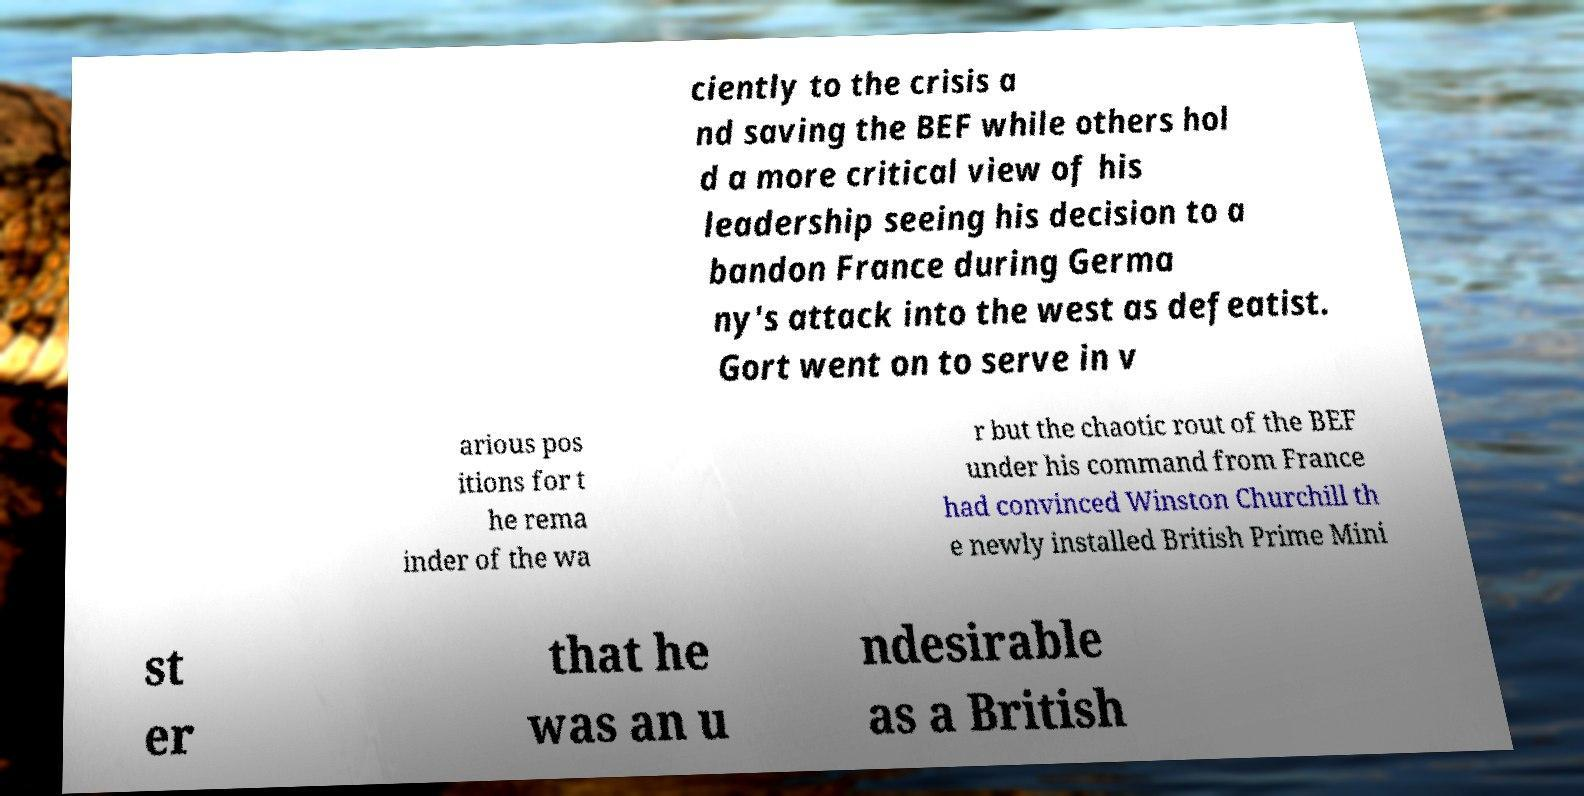Can you accurately transcribe the text from the provided image for me? ciently to the crisis a nd saving the BEF while others hol d a more critical view of his leadership seeing his decision to a bandon France during Germa ny's attack into the west as defeatist. Gort went on to serve in v arious pos itions for t he rema inder of the wa r but the chaotic rout of the BEF under his command from France had convinced Winston Churchill th e newly installed British Prime Mini st er that he was an u ndesirable as a British 